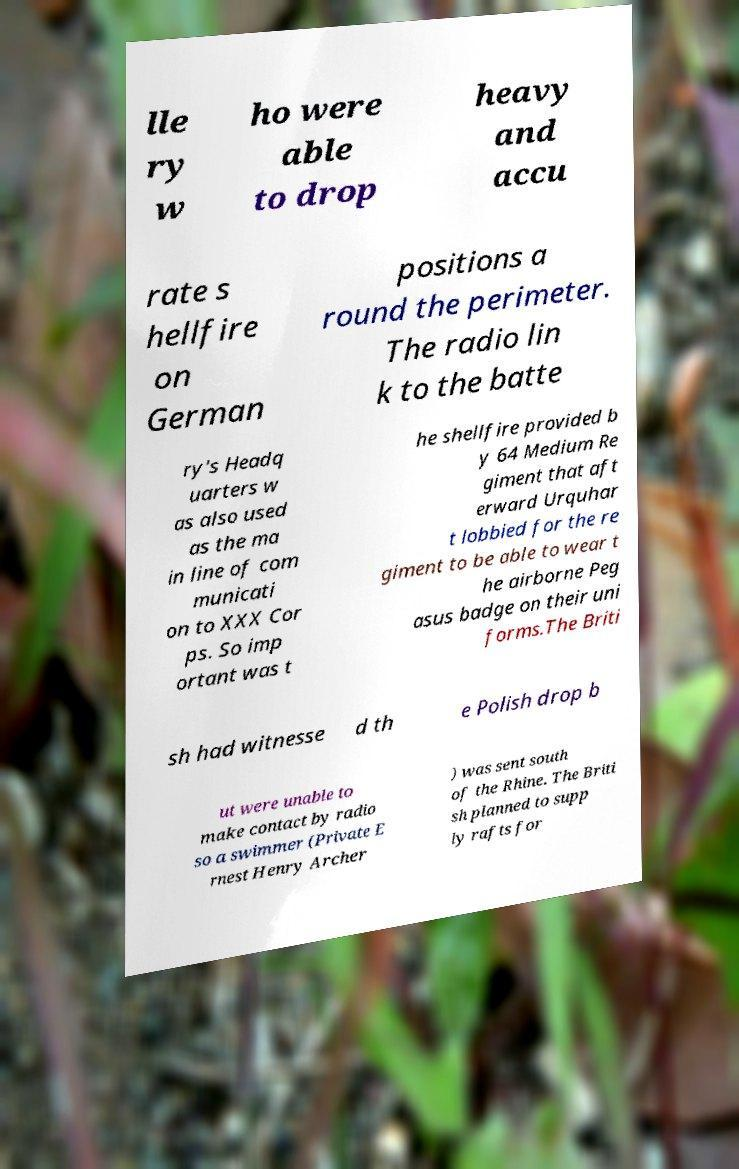For documentation purposes, I need the text within this image transcribed. Could you provide that? lle ry w ho were able to drop heavy and accu rate s hellfire on German positions a round the perimeter. The radio lin k to the batte ry's Headq uarters w as also used as the ma in line of com municati on to XXX Cor ps. So imp ortant was t he shellfire provided b y 64 Medium Re giment that aft erward Urquhar t lobbied for the re giment to be able to wear t he airborne Peg asus badge on their uni forms.The Briti sh had witnesse d th e Polish drop b ut were unable to make contact by radio so a swimmer (Private E rnest Henry Archer ) was sent south of the Rhine. The Briti sh planned to supp ly rafts for 